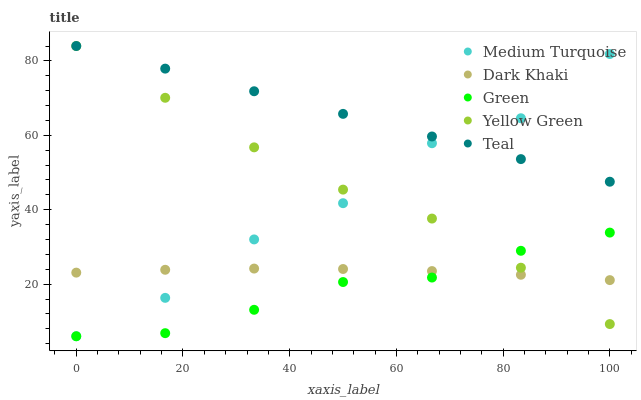Does Green have the minimum area under the curve?
Answer yes or no. Yes. Does Teal have the maximum area under the curve?
Answer yes or no. Yes. Does Teal have the minimum area under the curve?
Answer yes or no. No. Does Green have the maximum area under the curve?
Answer yes or no. No. Is Teal the smoothest?
Answer yes or no. Yes. Is Medium Turquoise the roughest?
Answer yes or no. Yes. Is Green the smoothest?
Answer yes or no. No. Is Green the roughest?
Answer yes or no. No. Does Green have the lowest value?
Answer yes or no. Yes. Does Teal have the lowest value?
Answer yes or no. No. Does Yellow Green have the highest value?
Answer yes or no. Yes. Does Green have the highest value?
Answer yes or no. No. Is Green less than Teal?
Answer yes or no. Yes. Is Teal greater than Green?
Answer yes or no. Yes. Does Yellow Green intersect Teal?
Answer yes or no. Yes. Is Yellow Green less than Teal?
Answer yes or no. No. Is Yellow Green greater than Teal?
Answer yes or no. No. Does Green intersect Teal?
Answer yes or no. No. 